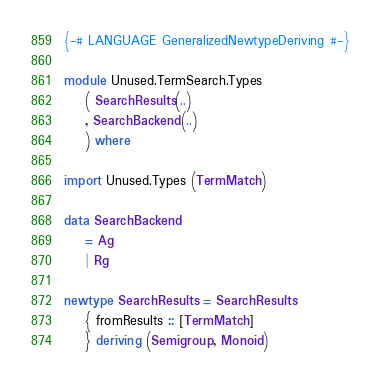<code> <loc_0><loc_0><loc_500><loc_500><_Haskell_>{-# LANGUAGE GeneralizedNewtypeDeriving #-}

module Unused.TermSearch.Types
    ( SearchResults(..)
    , SearchBackend(..)
    ) where

import Unused.Types (TermMatch)

data SearchBackend
    = Ag
    | Rg

newtype SearchResults = SearchResults
    { fromResults :: [TermMatch]
    } deriving (Semigroup, Monoid)
</code> 